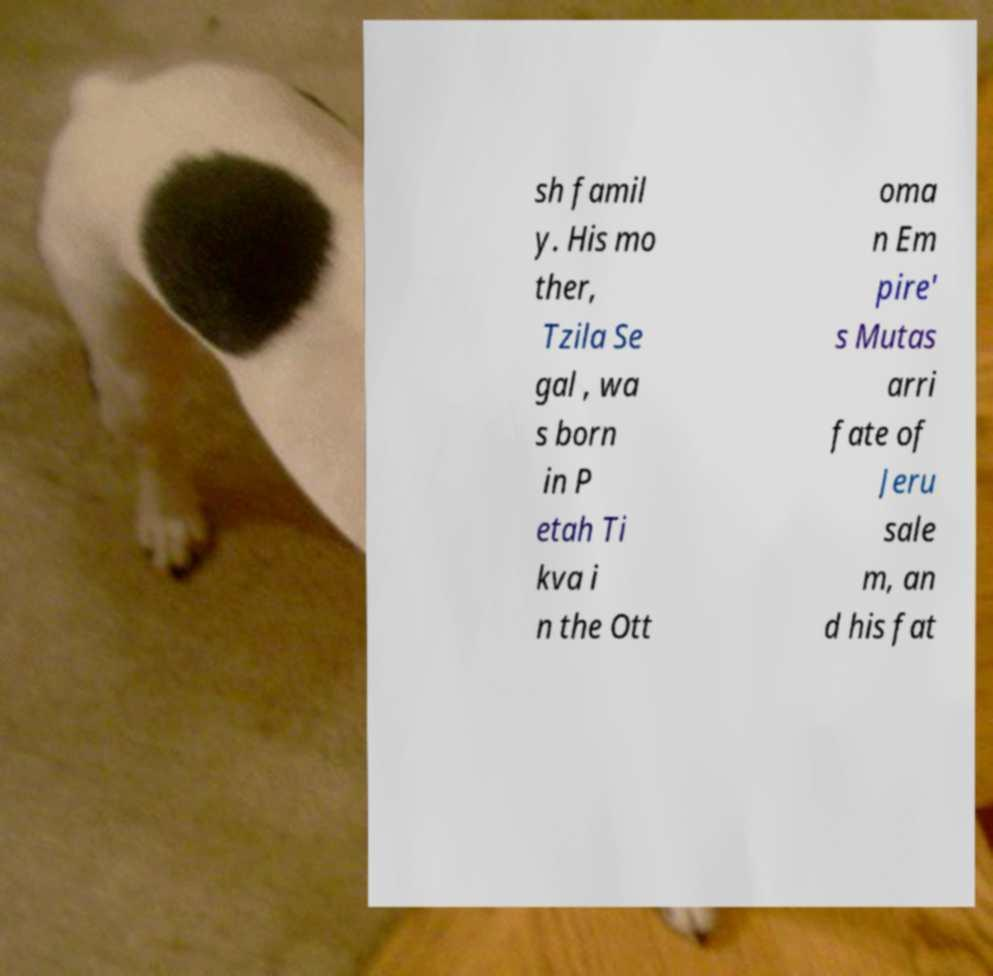Please identify and transcribe the text found in this image. sh famil y. His mo ther, Tzila Se gal , wa s born in P etah Ti kva i n the Ott oma n Em pire' s Mutas arri fate of Jeru sale m, an d his fat 